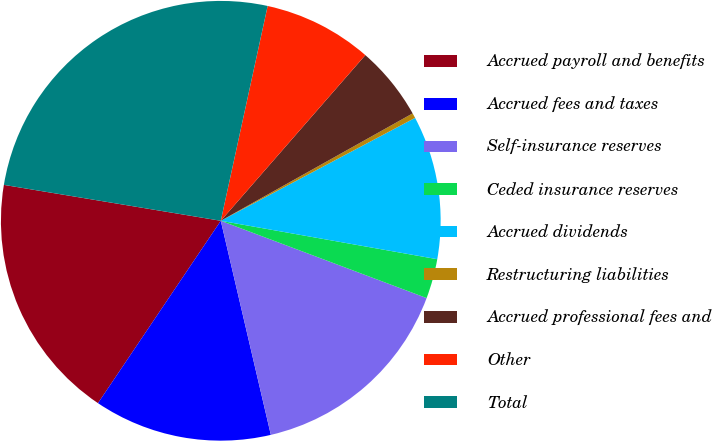Convert chart to OTSL. <chart><loc_0><loc_0><loc_500><loc_500><pie_chart><fcel>Accrued payroll and benefits<fcel>Accrued fees and taxes<fcel>Self-insurance reserves<fcel>Ceded insurance reserves<fcel>Accrued dividends<fcel>Restructuring liabilities<fcel>Accrued professional fees and<fcel>Other<fcel>Total<nl><fcel>18.18%<fcel>13.09%<fcel>15.63%<fcel>2.92%<fcel>10.55%<fcel>0.37%<fcel>5.46%<fcel>8.0%<fcel>25.81%<nl></chart> 